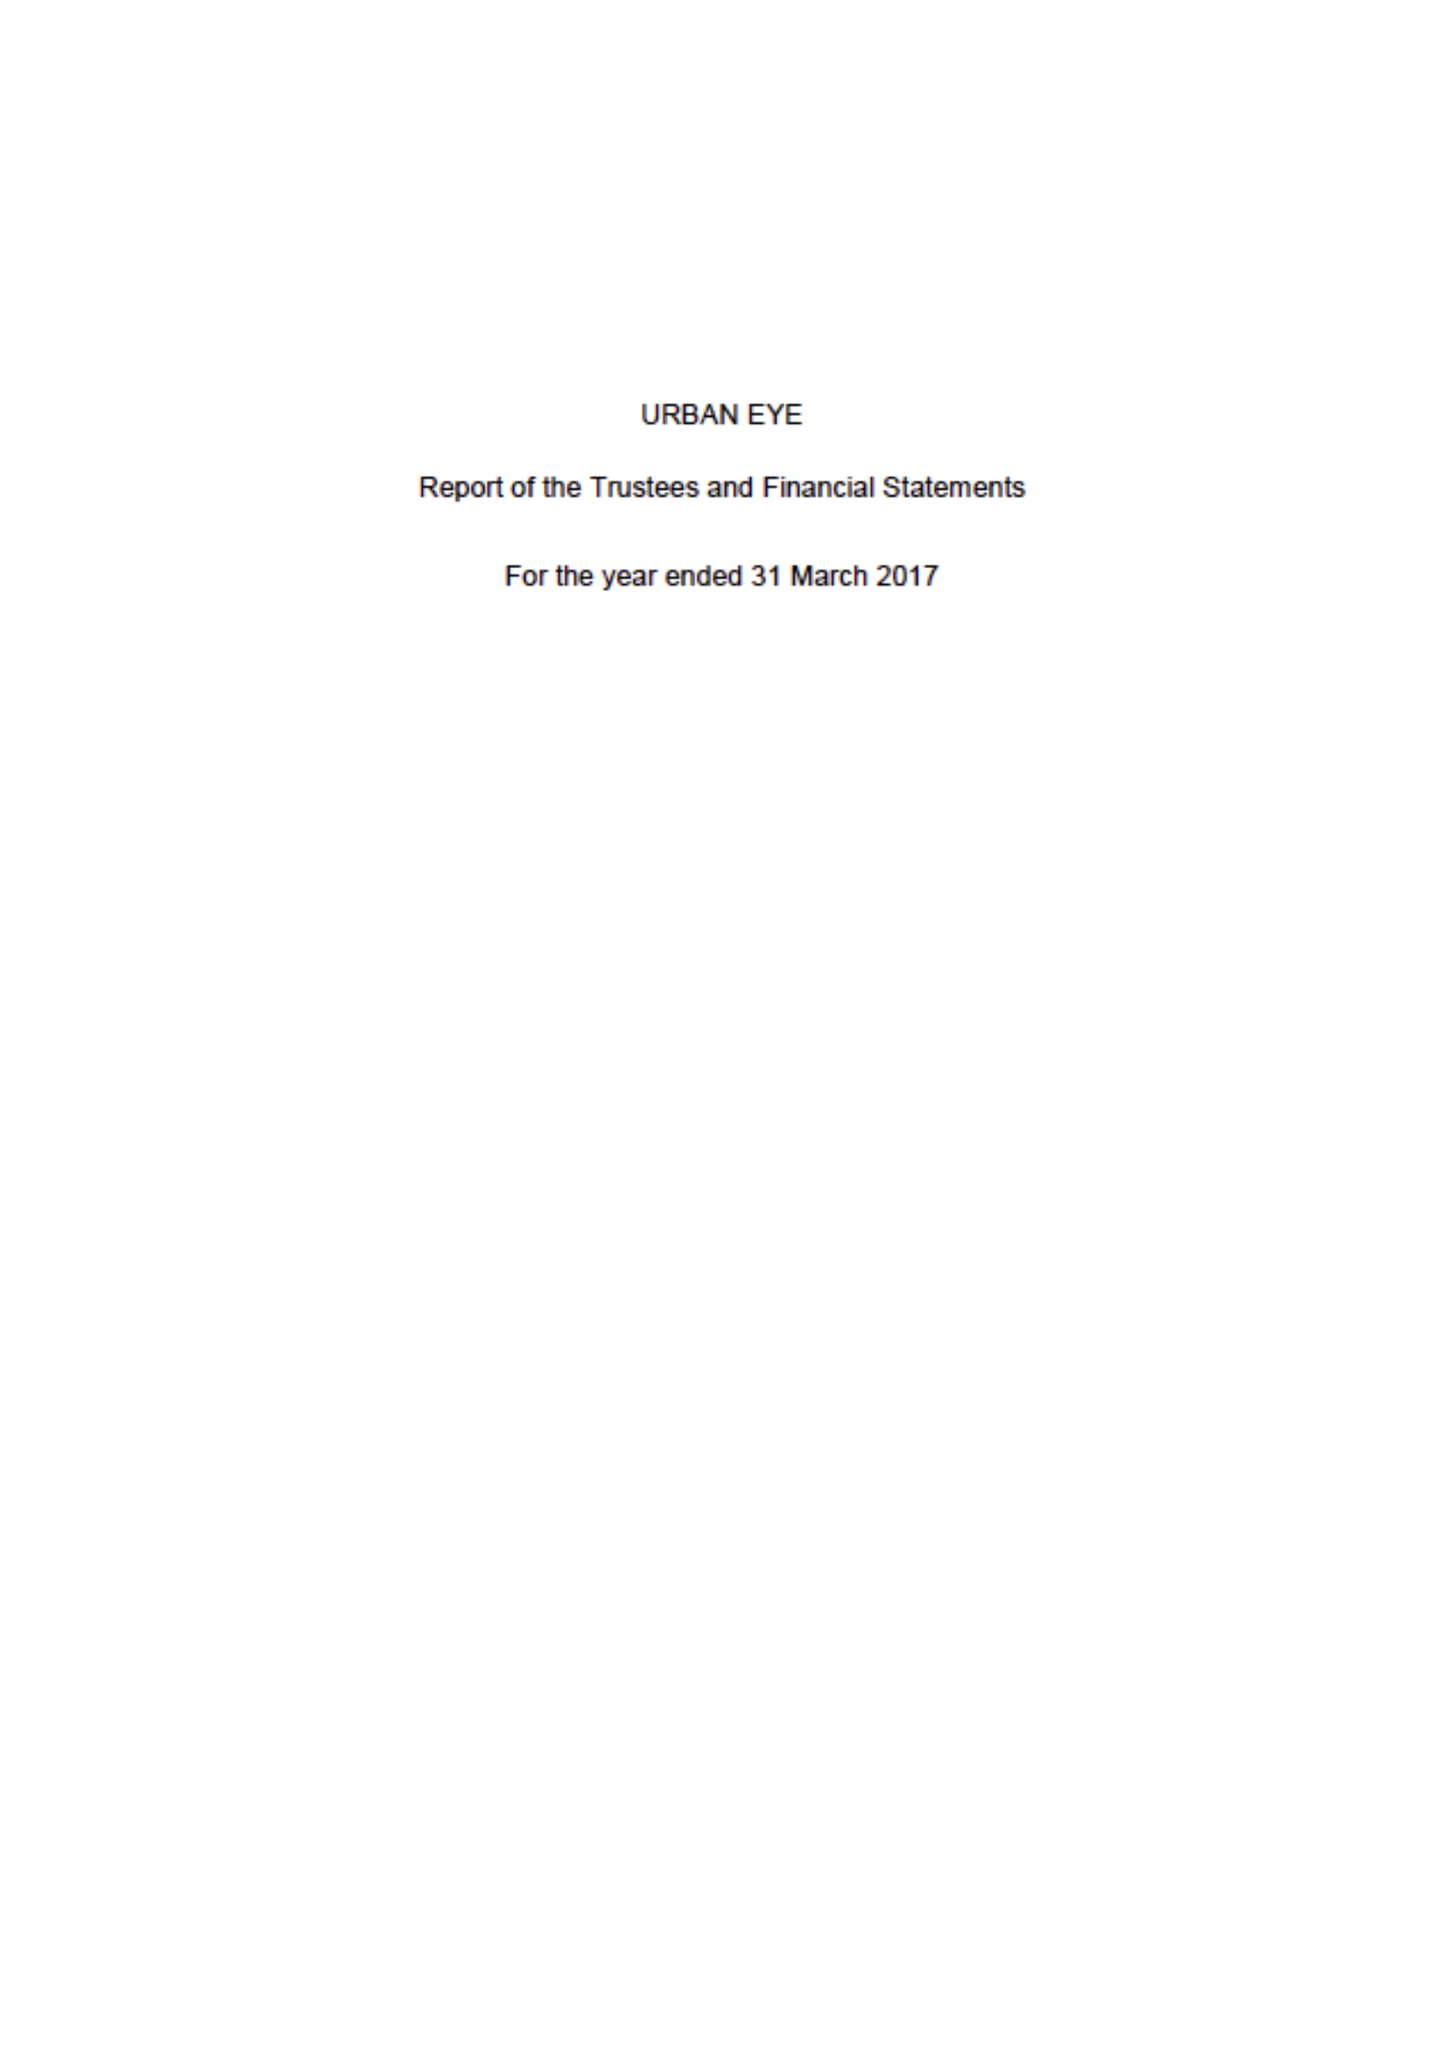What is the value for the charity_name?
Answer the question using a single word or phrase. Urban Eye 